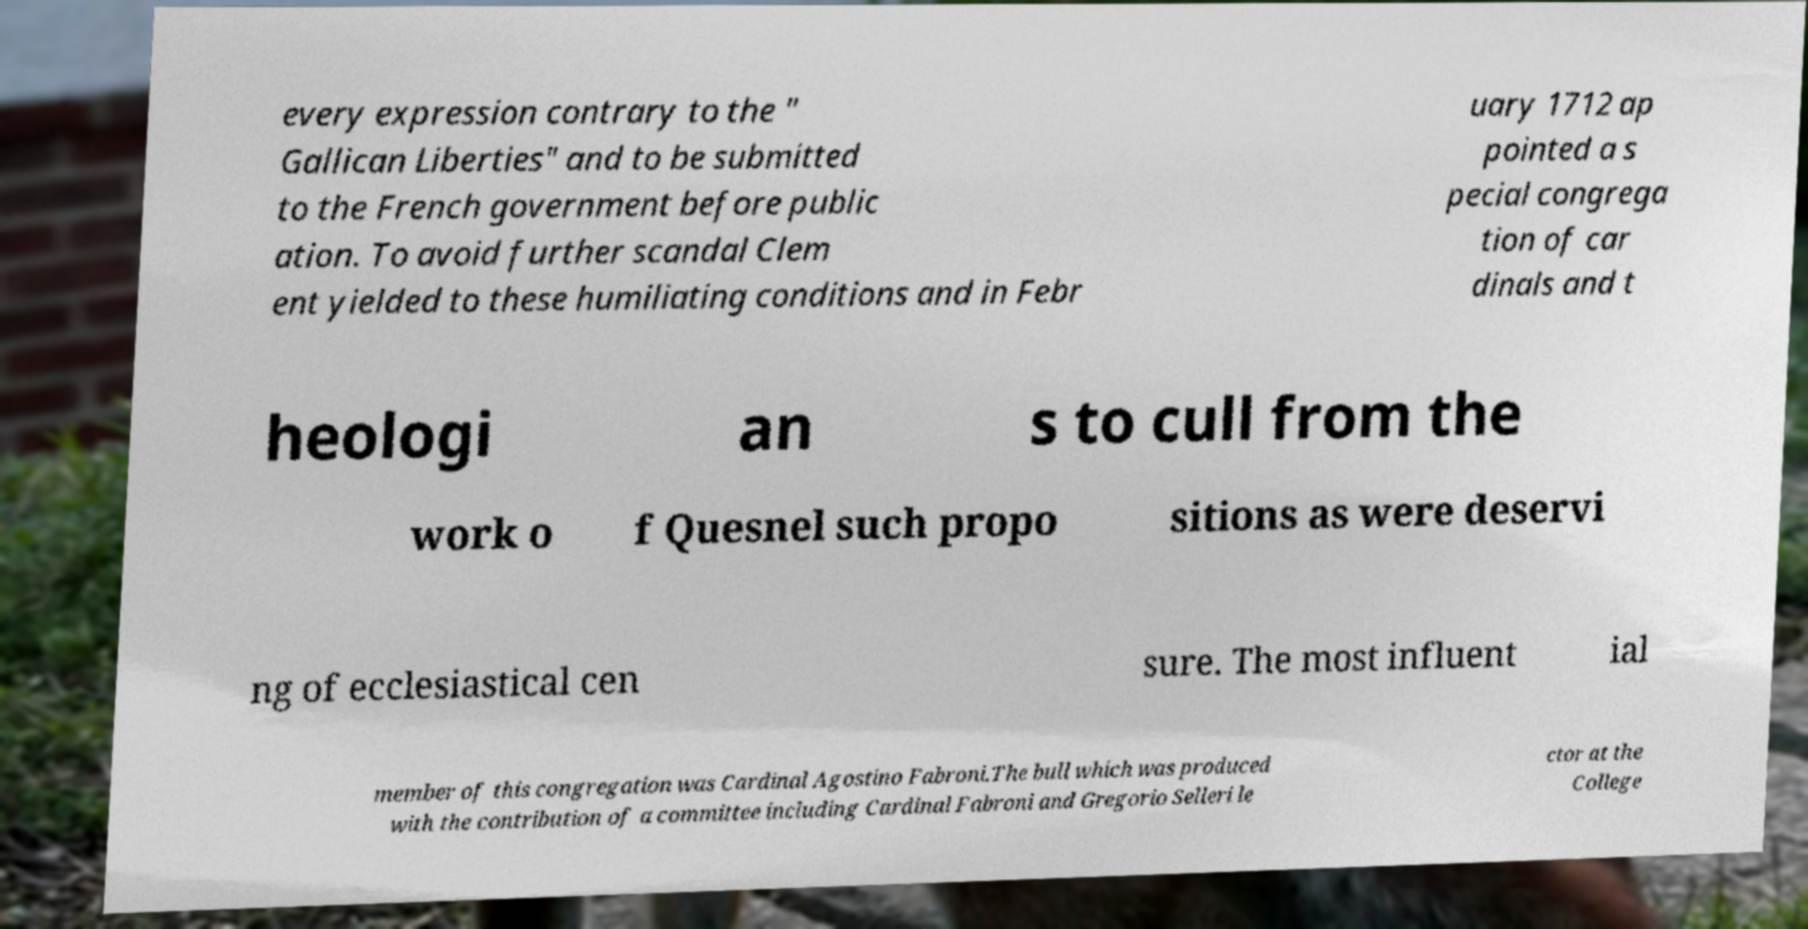Please identify and transcribe the text found in this image. every expression contrary to the " Gallican Liberties" and to be submitted to the French government before public ation. To avoid further scandal Clem ent yielded to these humiliating conditions and in Febr uary 1712 ap pointed a s pecial congrega tion of car dinals and t heologi an s to cull from the work o f Quesnel such propo sitions as were deservi ng of ecclesiastical cen sure. The most influent ial member of this congregation was Cardinal Agostino Fabroni.The bull which was produced with the contribution of a committee including Cardinal Fabroni and Gregorio Selleri le ctor at the College 